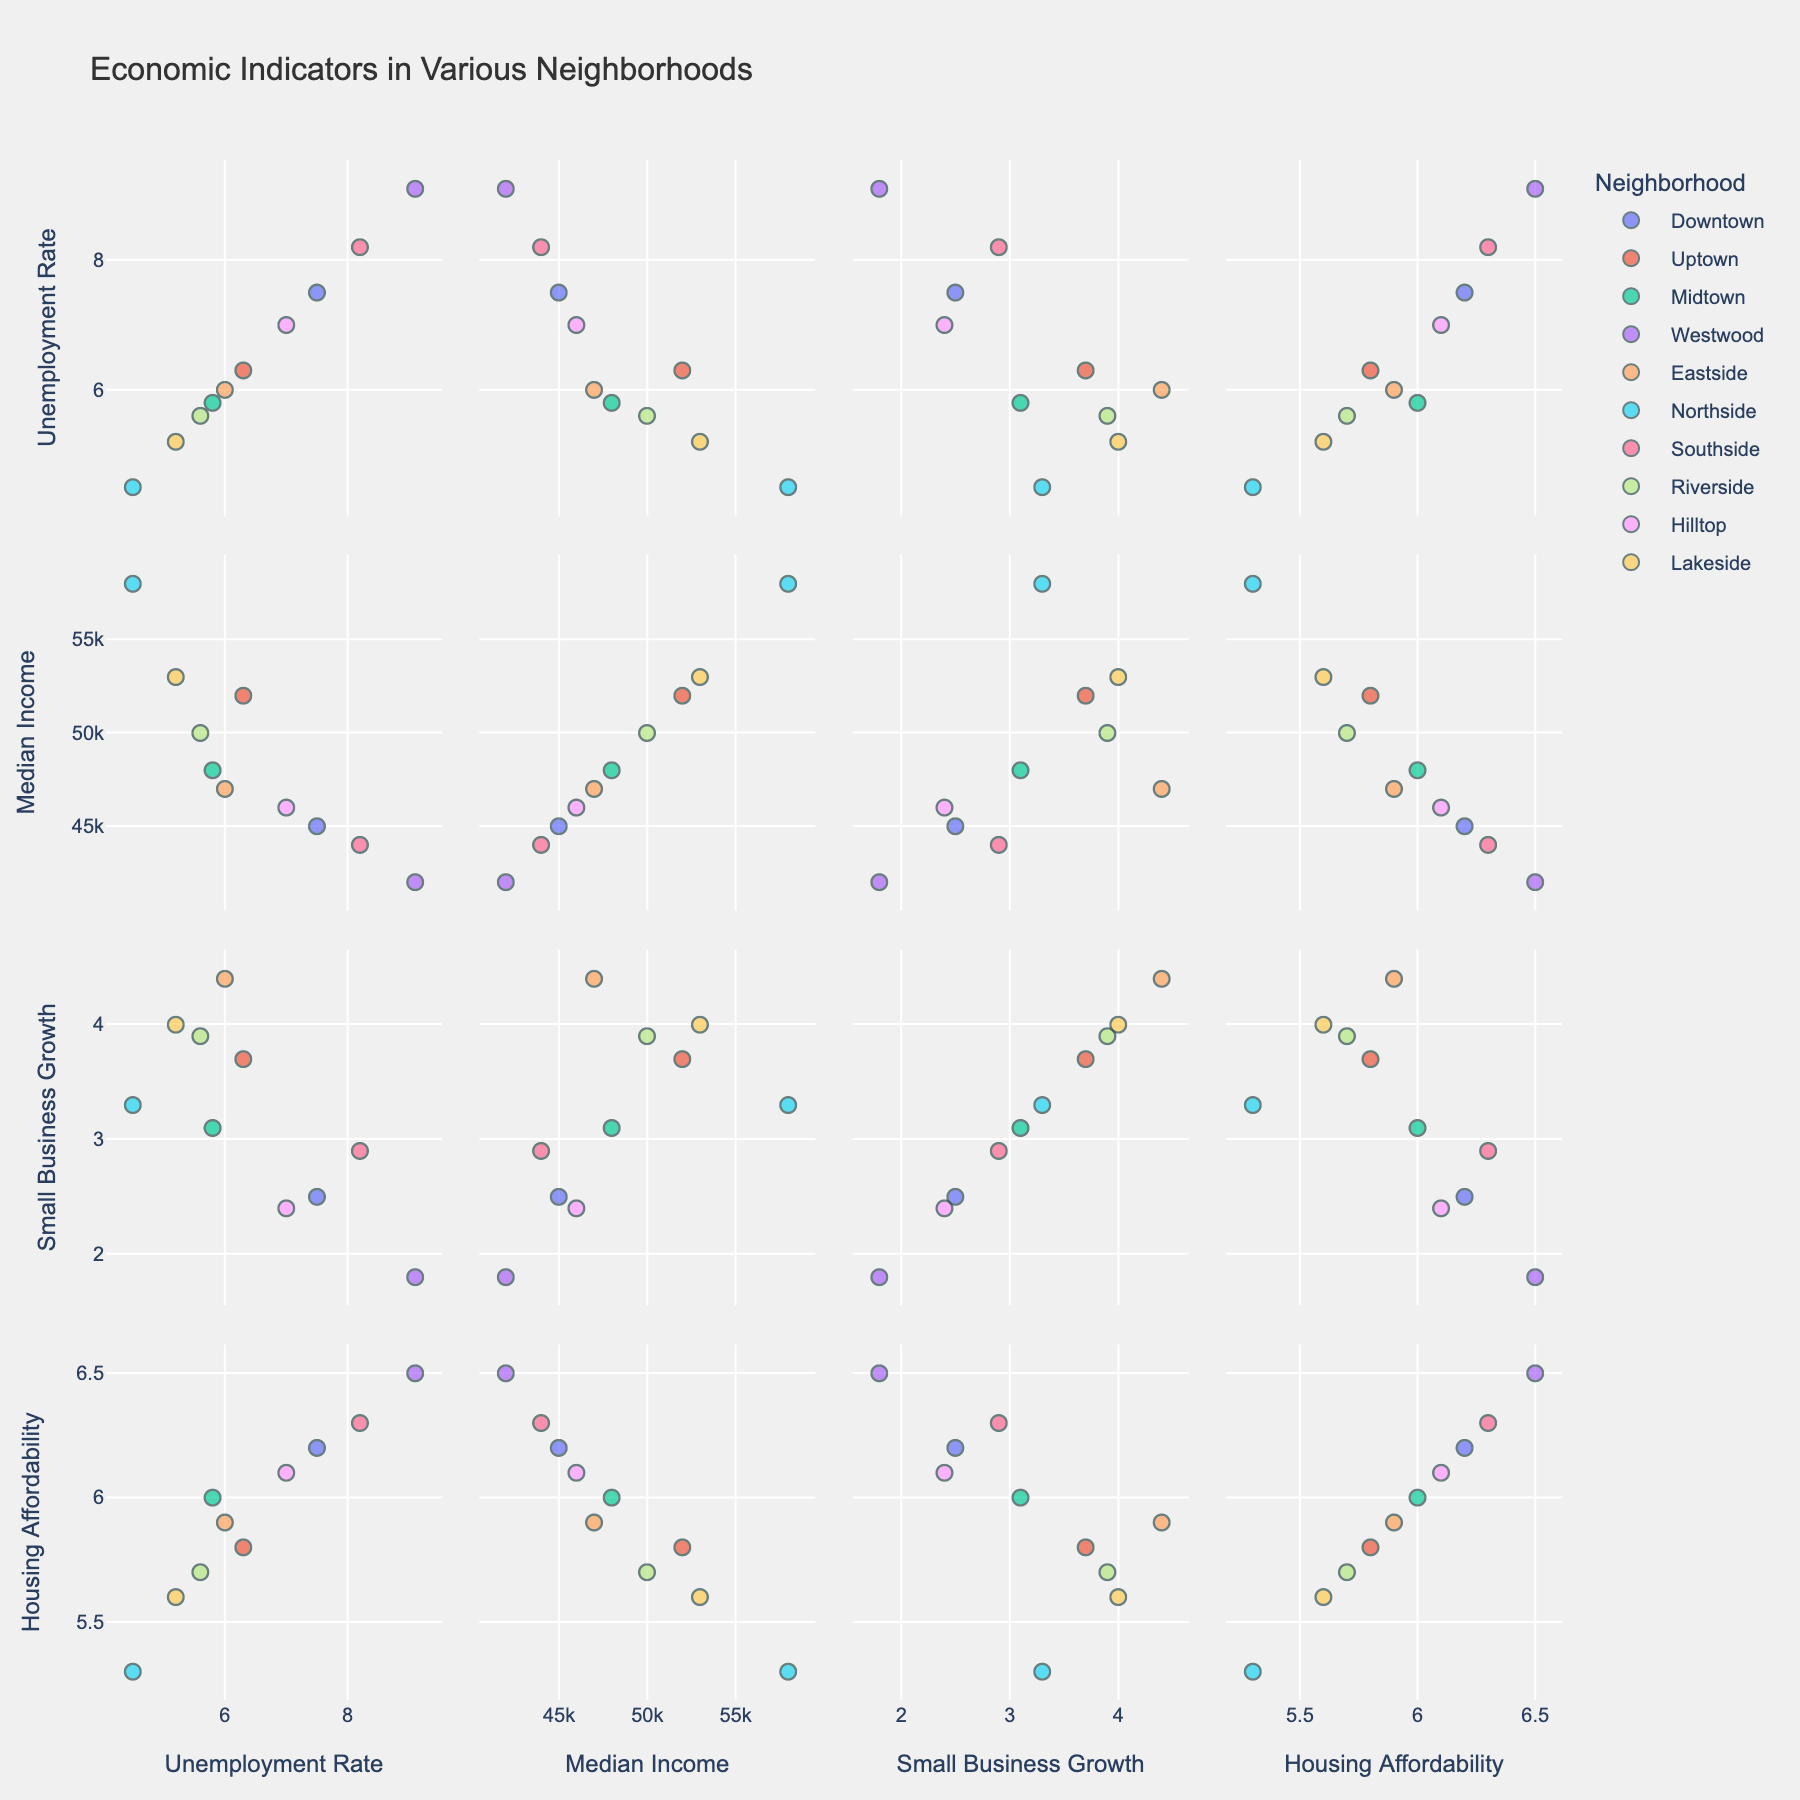What are the ranges for Median Income and Unemployment Rate? From the scatter plot matrix, locate the range of values for the Median Income and Unemployment Rate axes. For Median Income, it ranges from 42000 to 58000 dollars. For the Unemployment Rate, it ranges from 4.5% to 9.1%.
Answer: Median Income: 42000-58000, Unemployment Rate: 4.5%-9.1% Which neighborhood has the highest Small Business Growth (%)? Locate the Small Business Growth (%) on the scatter plot matrix and identify the point with the highest value. The Eastside neighborhood shows the highest Small Business Growth at 4.4%.
Answer: Eastside Compare the Unemployment Rate between Southside and Uptown. Which neighborhood has a higher rate? Look at the points representing Southside and Uptown in the Unemployment Rate dimension. The Unemployment Rate for Southside is 8.2%, which is higher than Uptown's 6.3%.
Answer: Southside How does Median Income relate to Housing Affordability across neighborhoods? Evaluate the scatter plots that show the relationship between Median Income and Housing Affordability. Generally, as Median Income increases, Housing Affordability (ratio) tends to decrease, showing an inverse relationship.
Answer: Inverse relationship Is there any neighborhood where high Median Income coincides with high Small Business Growth? Analyze the scatter plot with Median Income on one axis and Small Business Growth on the other. Lakeside, with a high Median Income of $53000 and Small Business Growth of 4.0%, fits this description.
Answer: Lakeside What is the Housing Affordability ratio for Riverside? Identify Riverside in the datasets and locate its value for the Housing Affordability axis. Riverside's Housing Affordability ratio is 5.7.
Answer: 5.7 Which neighborhood has the lowest Unemployment Rate, and what is their Median Income? Find the neighborhood with the minimum value on the Unemployment Rate axis and then check its Median Income. Northside has the lowest Unemployment Rate at 4.5% and a Median Income of $58000.
Answer: Northside, $58000 Among Eastside and Hilltop, which has a better ratio of Small Business Growth to Housing Affordability? Calculate the ratio of Small Business Growth to Housing Affordability for both neighborhoods. Eastside: 4.4/5.9 ~ 0.75, Hilltop: 2.4/6.1 ~ 0.39. Eastside has a better ratio.
Answer: Eastside Which neighborhoods fall below a 6% Unemployment Rate and what are their range of Median Incomes? Identify the neighborhoods with Unemployment Rates below 6% and list their Median Incomes. Midtown, Eastside, Northside, Riverside, and Lakeside fall below 6% with Median Incomes ranging from $47000 to $58000.
Answer: Midtown, Eastside, Northside, Riverside, Lakeside; $47000-$58000 